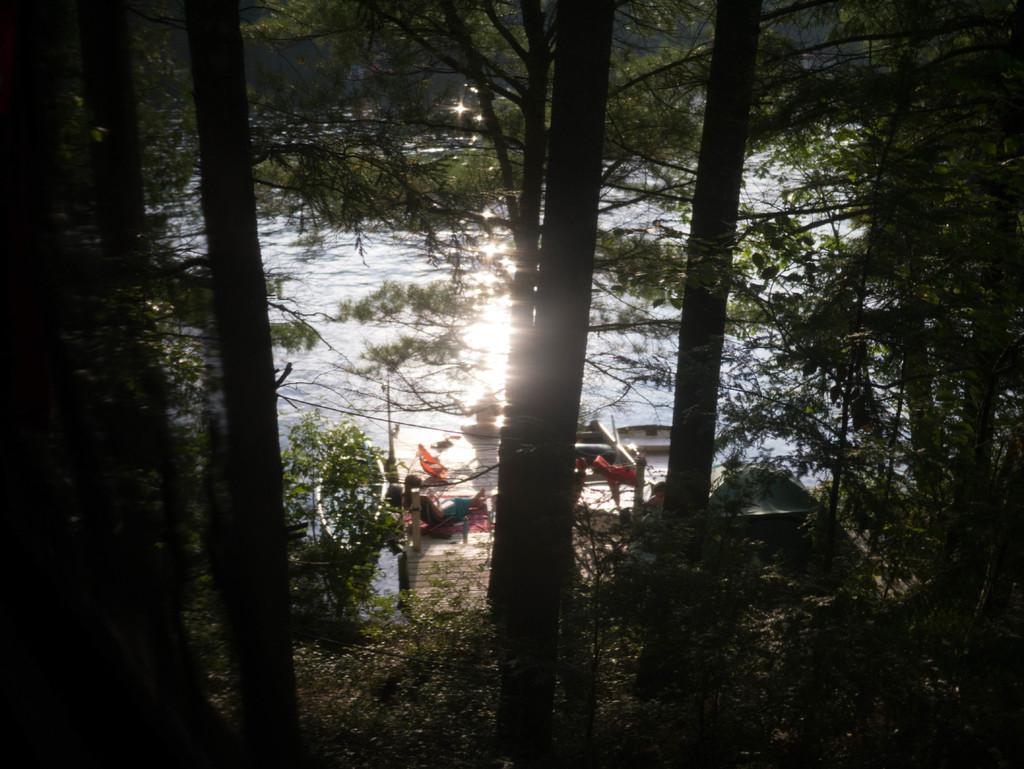Could you give a brief overview of what you see in this image? In the center of the image we can see bridge, person, clothes, boats, umbrella. In the background of the image we can see trees and water. At the bottom of the image we can see the ground. 